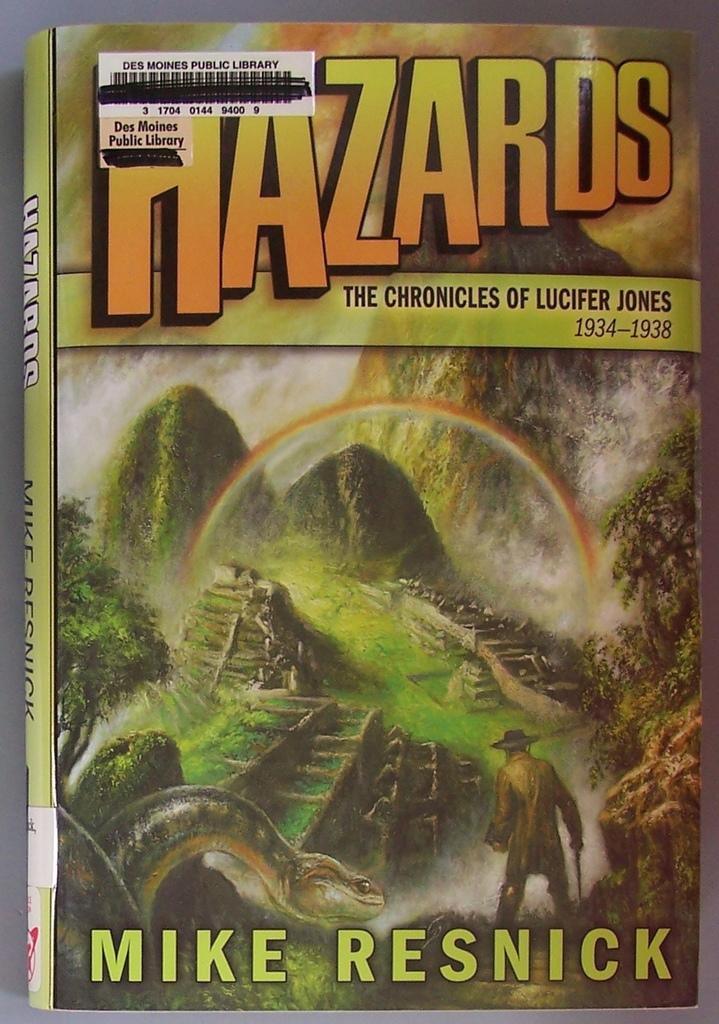What is the author's name?
Your answer should be compact. Mike resnick. What is the name of this book?
Your answer should be very brief. Hazards. 